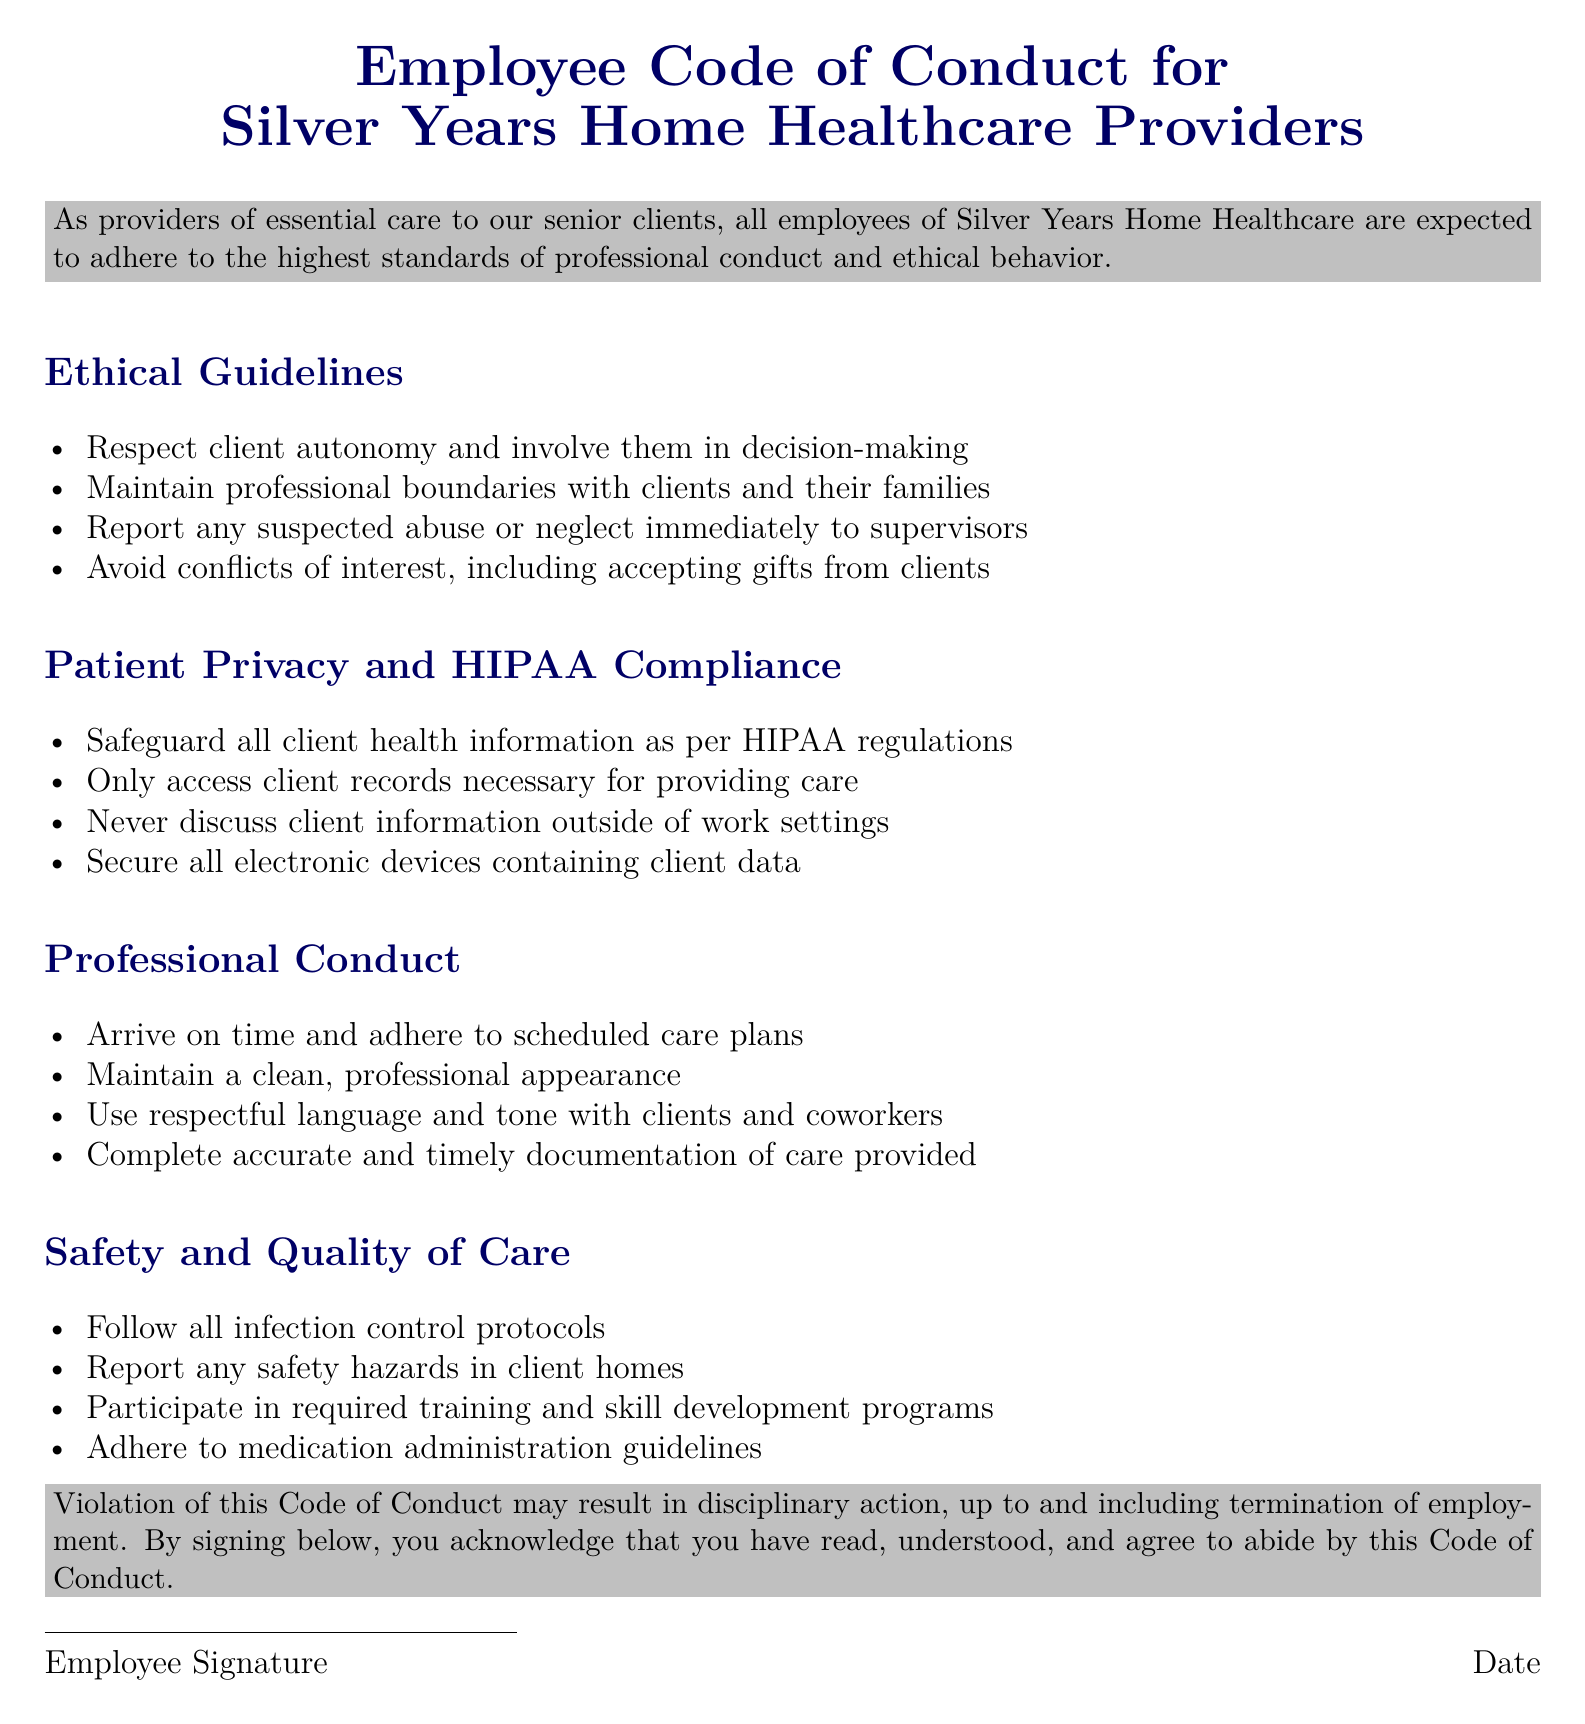What are the expectations for maintaining professional boundaries? The guidelines specify that employees should maintain professional boundaries with clients and their families.
Answer: Maintain professional boundaries What should employees do if they suspect abuse or neglect? The document states that employees must report any suspected abuse or neglect immediately to supervisors.
Answer: Report to supervisors What does HIPAA stand for in the context of patient privacy? HIPAA refers to the Health Insurance Portability and Accountability Act relevant to safeguarding client health information.
Answer: Health Insurance Portability and Accountability Act What should an employee do to prevent conflicts of interest? Employees must avoid conflicts of interest, including accepting gifts from clients.
Answer: Avoid accepting gifts How should employees handle client health information? Employees should safeguard all client health information as per HIPAA regulations.
Answer: Safeguard all client health information What is the consequence of violating the Code of Conduct? The document indicates that violation may result in disciplinary action, up to and including termination of employment.
Answer: Disciplinary action or termination How often should employees participate in training programs? Employees are required to participate in training and skill development programs as outlined in the safety section.
Answer: Required participation What language should be used when communicating with clients? Employees are expected to use respectful language and tone with clients and coworkers.
Answer: Respectful language and tone What is one of the requirements for completing client documentation? Employees must complete accurate and timely documentation of care provided to clients.
Answer: Accurate and timely documentation 